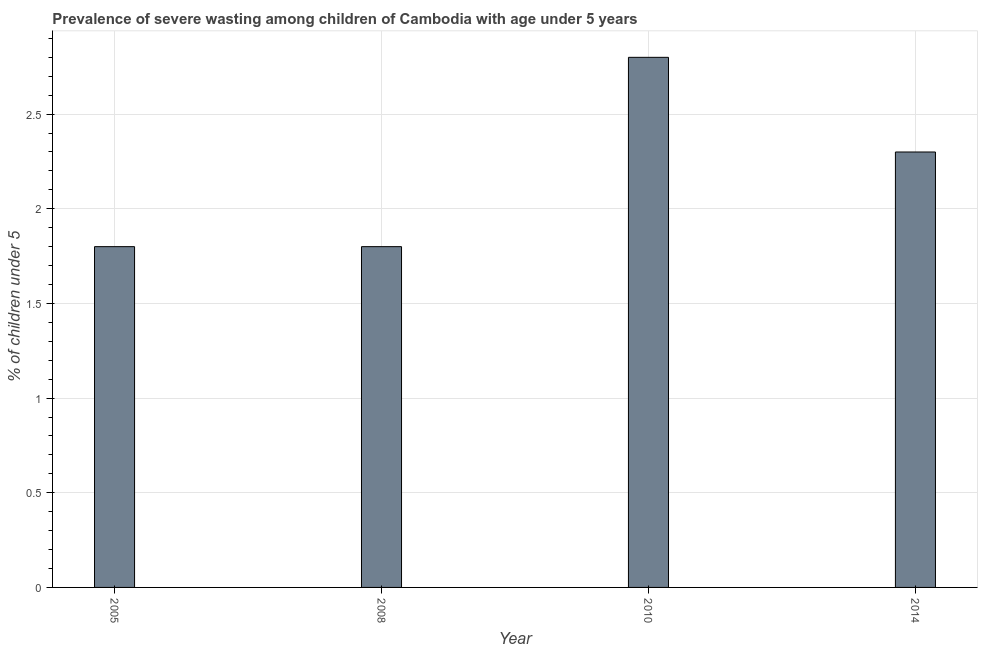Does the graph contain any zero values?
Provide a short and direct response. No. What is the title of the graph?
Offer a terse response. Prevalence of severe wasting among children of Cambodia with age under 5 years. What is the label or title of the X-axis?
Offer a very short reply. Year. What is the label or title of the Y-axis?
Make the answer very short.  % of children under 5. What is the prevalence of severe wasting in 2010?
Make the answer very short. 2.8. Across all years, what is the maximum prevalence of severe wasting?
Your answer should be very brief. 2.8. Across all years, what is the minimum prevalence of severe wasting?
Your response must be concise. 1.8. In which year was the prevalence of severe wasting maximum?
Offer a terse response. 2010. What is the sum of the prevalence of severe wasting?
Keep it short and to the point. 8.7. What is the difference between the prevalence of severe wasting in 2008 and 2014?
Ensure brevity in your answer.  -0.5. What is the average prevalence of severe wasting per year?
Keep it short and to the point. 2.17. What is the median prevalence of severe wasting?
Your response must be concise. 2.05. Do a majority of the years between 2008 and 2010 (inclusive) have prevalence of severe wasting greater than 0.8 %?
Your response must be concise. Yes. What is the ratio of the prevalence of severe wasting in 2005 to that in 2014?
Make the answer very short. 0.78. Is the prevalence of severe wasting in 2005 less than that in 2008?
Ensure brevity in your answer.  No. Is the difference between the prevalence of severe wasting in 2005 and 2014 greater than the difference between any two years?
Your response must be concise. No. Is the sum of the prevalence of severe wasting in 2005 and 2010 greater than the maximum prevalence of severe wasting across all years?
Offer a terse response. Yes. What is the difference between the highest and the lowest prevalence of severe wasting?
Provide a succinct answer. 1. In how many years, is the prevalence of severe wasting greater than the average prevalence of severe wasting taken over all years?
Ensure brevity in your answer.  2. How many bars are there?
Provide a succinct answer. 4. How many years are there in the graph?
Offer a very short reply. 4. What is the difference between two consecutive major ticks on the Y-axis?
Give a very brief answer. 0.5. What is the  % of children under 5 in 2005?
Offer a very short reply. 1.8. What is the  % of children under 5 of 2008?
Your answer should be compact. 1.8. What is the  % of children under 5 in 2010?
Keep it short and to the point. 2.8. What is the  % of children under 5 in 2014?
Give a very brief answer. 2.3. What is the difference between the  % of children under 5 in 2005 and 2008?
Make the answer very short. 0. What is the difference between the  % of children under 5 in 2008 and 2014?
Make the answer very short. -0.5. What is the ratio of the  % of children under 5 in 2005 to that in 2008?
Offer a terse response. 1. What is the ratio of the  % of children under 5 in 2005 to that in 2010?
Your answer should be very brief. 0.64. What is the ratio of the  % of children under 5 in 2005 to that in 2014?
Your answer should be compact. 0.78. What is the ratio of the  % of children under 5 in 2008 to that in 2010?
Your answer should be very brief. 0.64. What is the ratio of the  % of children under 5 in 2008 to that in 2014?
Provide a short and direct response. 0.78. What is the ratio of the  % of children under 5 in 2010 to that in 2014?
Offer a terse response. 1.22. 